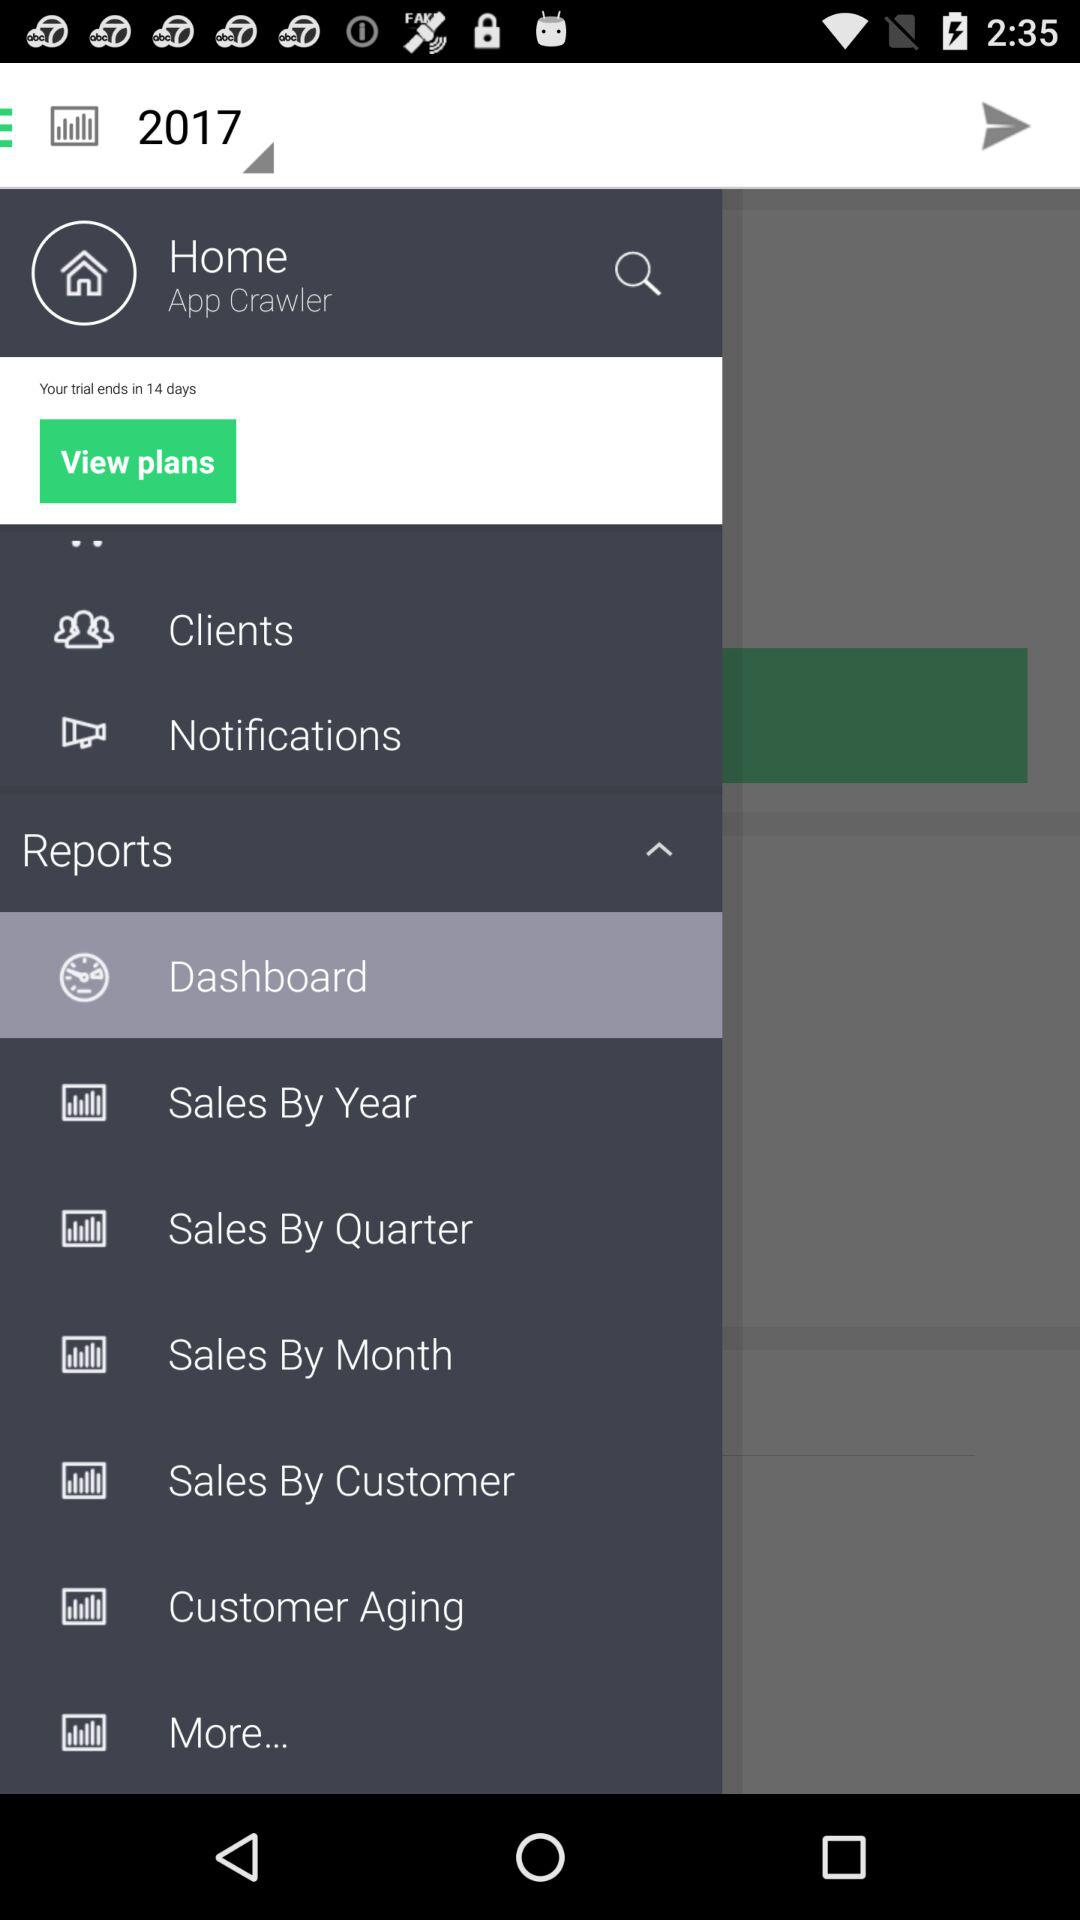How long will the trial last? The trial will last for 14 days. 